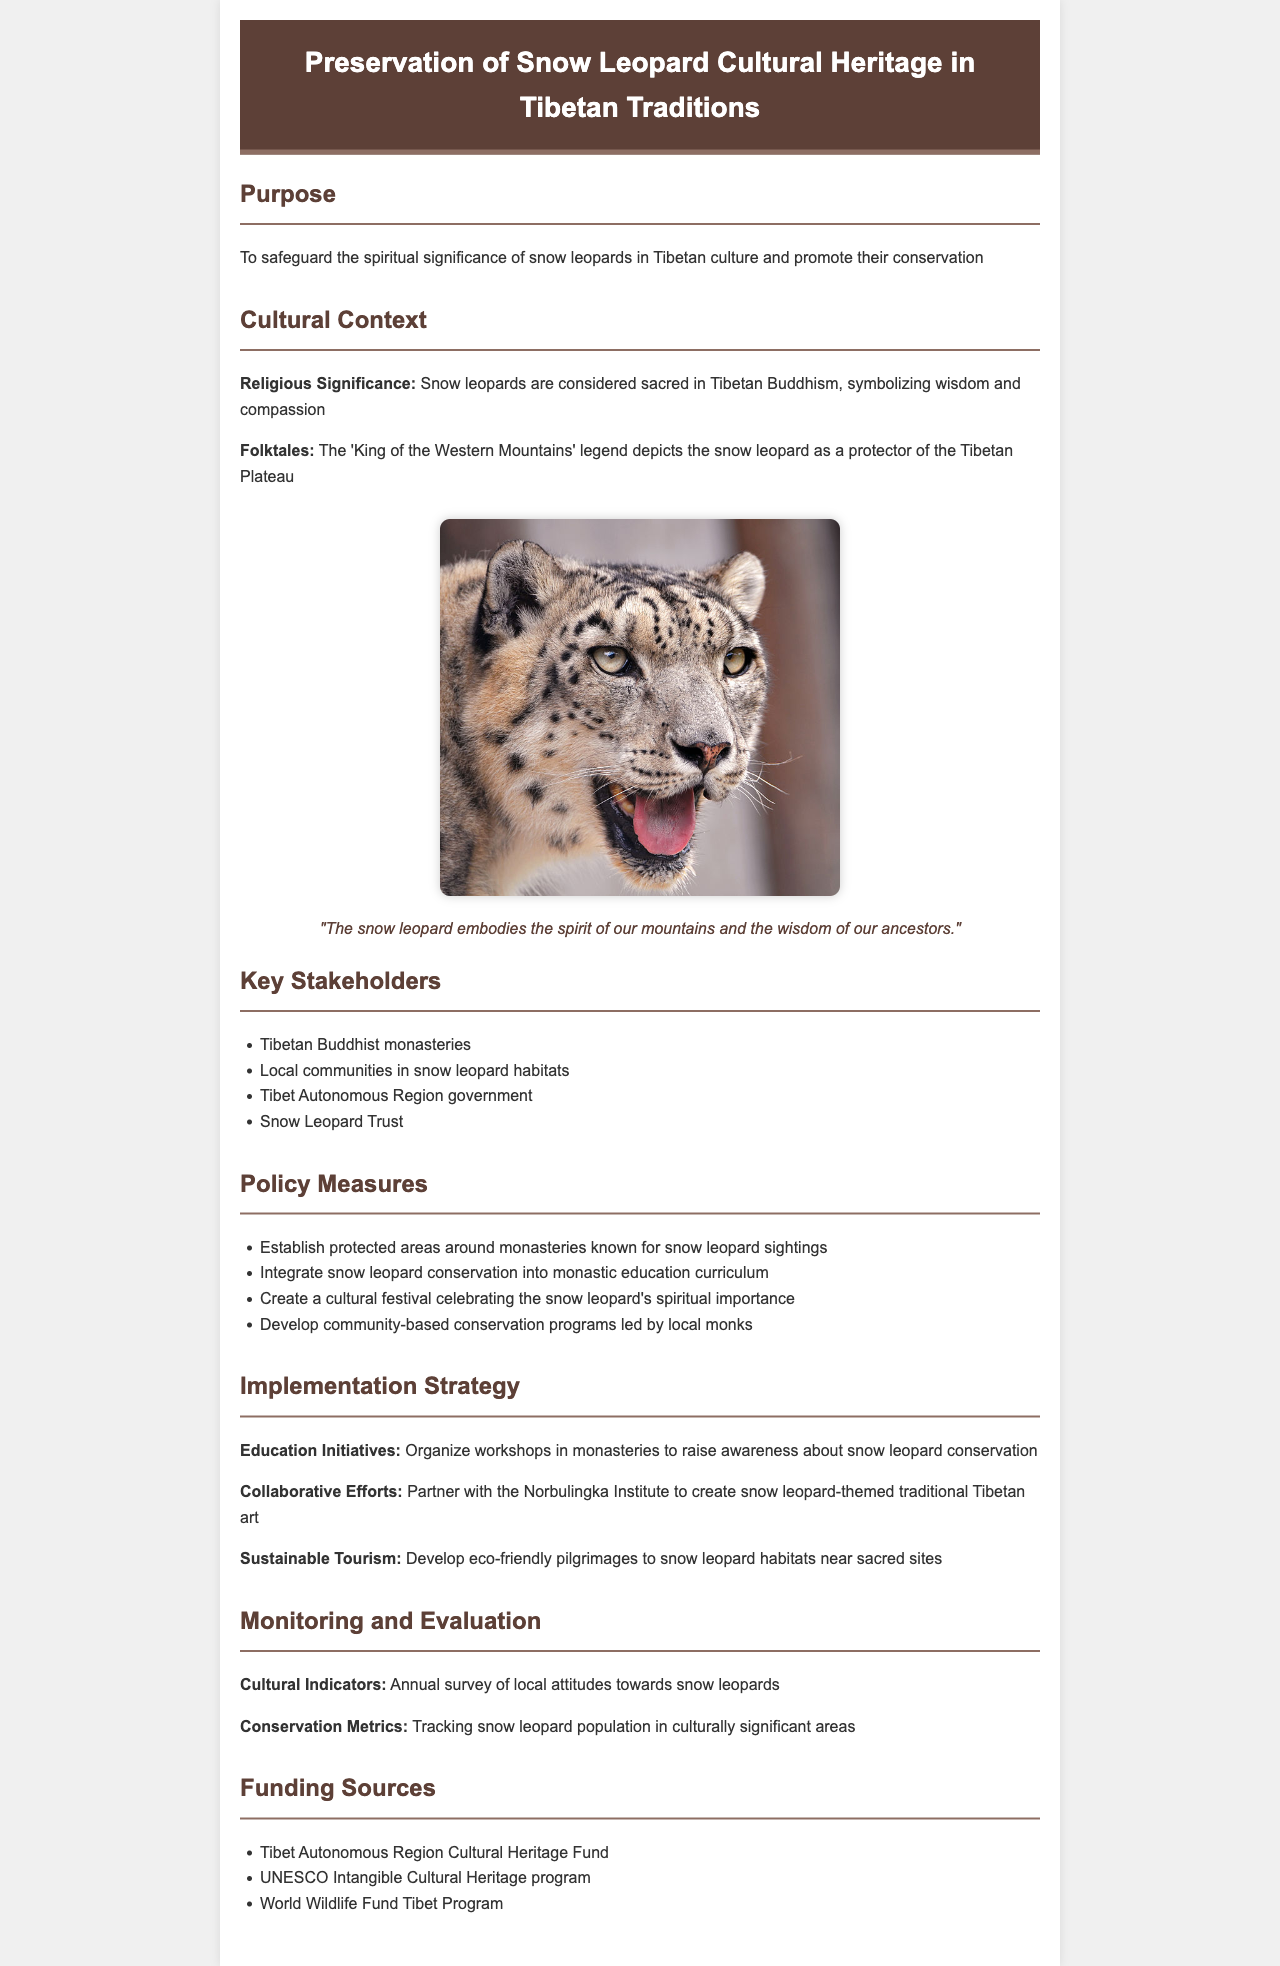what is the purpose of the policy? The purpose is to safeguard the spiritual significance of snow leopards in Tibetan culture and promote their conservation.
Answer: safeguard the spiritual significance of snow leopards in Tibetan culture and promote their conservation which entity is listed as a key stakeholder? The document lists Tibetan Buddhist monasteries as one of the key stakeholders involved in the preservation efforts.
Answer: Tibetan Buddhist monasteries what is one of the cultural contexts for snow leopards? The document highlights that snow leopards are considered sacred in Tibetan Buddhism, representing wisdom and compassion.
Answer: sacred in Tibetan Buddhism, symbolizing wisdom and compassion how many policy measures are listed? The document outlines four specific policy measures aimed at preserving the cultural heritage related to snow leopards.
Answer: four what is one type of funding source mentioned? The Tibet Autonomous Region Cultural Heritage Fund is mentioned as a source of funding for cultural heritage preservation.
Answer: Tibet Autonomous Region Cultural Heritage Fund what does the quote in the document emphasize? The quote emphasizes the connection between the snow leopard and the spirit of the mountains along with ancestral wisdom.
Answer: the spirit of our mountains and the wisdom of our ancestors what collaborative effort is proposed in the implementation strategy? The policy proposes partnering with the Norbulingka Institute to create snow leopard-themed traditional Tibetan art.
Answer: partner with the Norbulingka Institute to create snow leopard-themed traditional Tibetan art how often will attitudes towards snow leopards be surveyed? The document states that local attitudes toward snow leopards will be surveyed annually.
Answer: annually what is a sustainable tourism initiative mentioned? The document mentions developing eco-friendly pilgrimages to snow leopard habitats near sacred sites as a sustainable tourism initiative.
Answer: eco-friendly pilgrimages to snow leopard habitats near sacred sites 